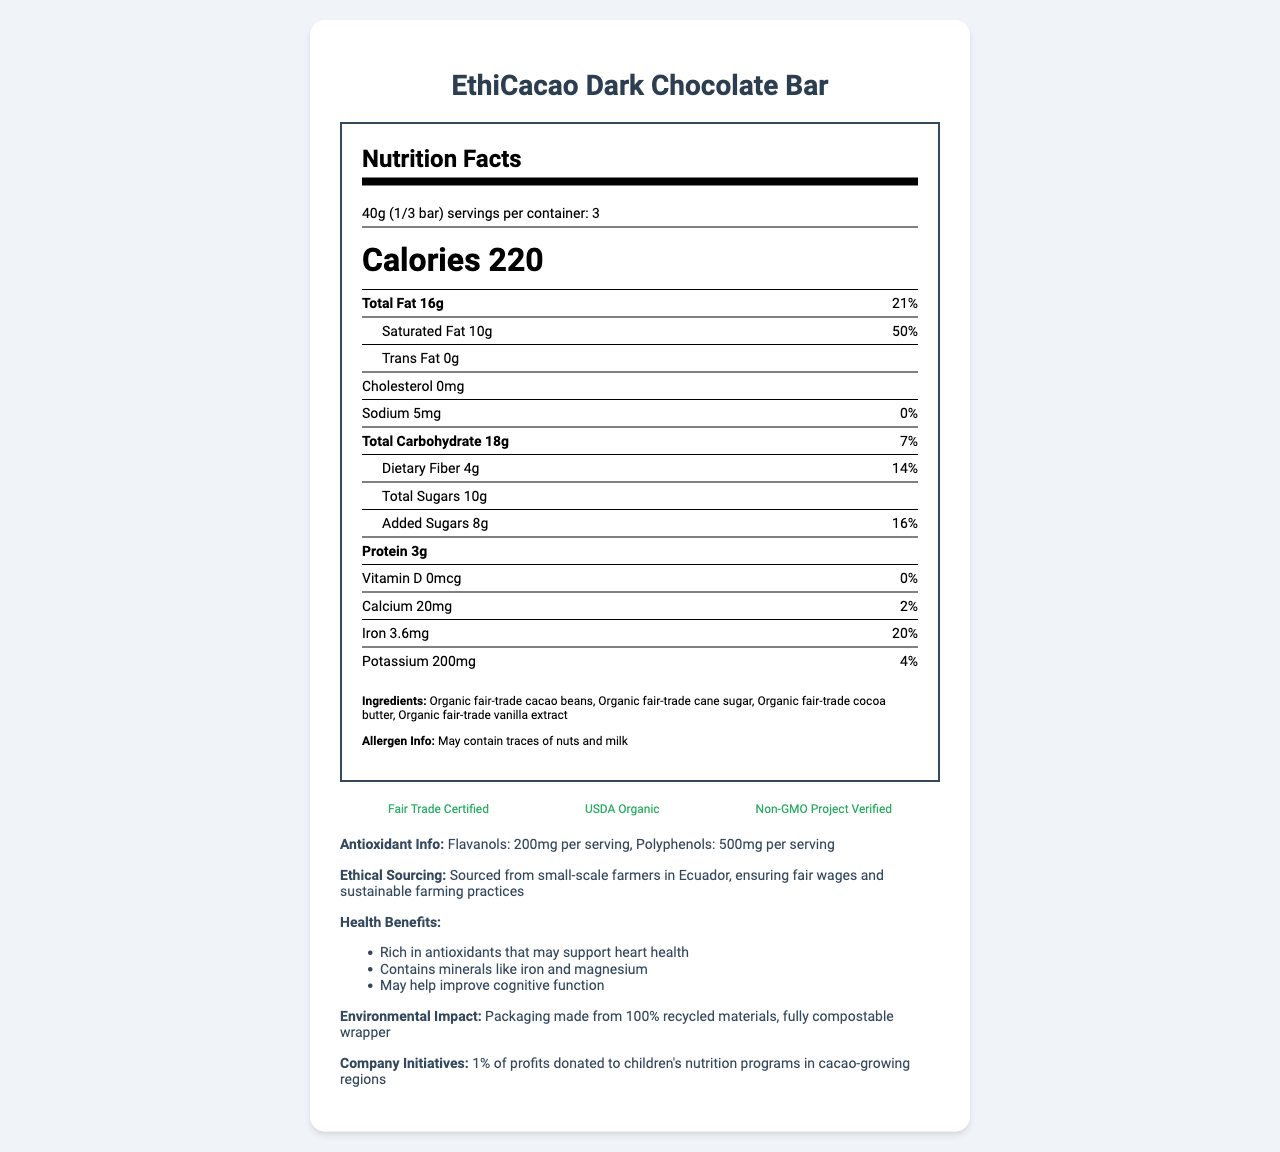what is the serving size of EthiCacao Dark Chocolate Bar? The document indicates that the serving size is specified as 40g (1/3 bar).
Answer: 40g (1/3 bar) how many servings per container are there? The document specifies that there are 3 servings per container of the chocolate bar.
Answer: 3 what are the total calories per serving? The number of calories per serving is listed as 220 in the document.
Answer: 220 what percentage of daily value does the saturated fat content represent? According to the document, the saturated fat content is 10g which represents 50% of the daily value.
Answer: 50% how much iron is in each serving and what percentage of daily value does it provide? The document notes that each serving contains 3.6mg of iron, which is 20% of the daily value.
Answer: 3.6mg, 20% which ingredient listed is not organic? The document lists all the ingredients as organic: Organic fair-trade cacao beans, Organic fair-trade cane sugar, Organic fair-trade cocoa butter, and Organic fair-trade vanilla extract.
Answer: None, all ingredients are organic what are the potential allergens in this product? The document specifies that the chocolate bar may contain traces of nuts and milk.
Answer: Trace amounts of nuts and milk what certifications does EthiCacao Dark Chocolate Bar have? A. Fair Trade Certified B. USDA Organic C. Non-GMO Project Verified D. All of the above The document lists the certifications as Fair Trade Certified, USDA Organic, and Non-GMO Project Verified.
Answer: D which of the following is NOT one of the company’s initiatives? A. 1% of profits donated to children's nutrition programs B. Sponsoring local marathons C. Ethical sourcing from Ecuador D. Using 100% recycled materials for packaging The document details several initiatives including donating 1% of profits to children's nutrition programs, ethical sourcing from Ecuador, and using 100% recycled packaging. Sponsoring local marathons is not mentioned.
Answer: B does the company claim environmental impact measures? The document states that the packaging is made from 100% recycled materials and is fully compostable.
Answer: Yes summarize the main benefits noted for the EthiCacao Dark Chocolate Bar. The product is highlighted as being rich in antioxidants (flavanols and polyphenols), high in minerals like iron and magnesium, and beneficial for heart health and cognitive function. Additionally, it is sourced ethically from small-scale farmers in Ecuador, and the packaging is environmentally friendly.
Answer: Antioxidant-rich, high in minerals, supports heart health and cognitive function, ethically sourced, environmentally friendly packaging what is the exact amount of vitamin D per serving in the chocolate bar? The document mentions that the vitamin D content per serving is 0mcg.
Answer: 0mcg how many grams of dietary fiber are in one serving and what is the percentage of daily value? Each serving contains 4g of dietary fiber, which represents 14% of the daily value.
Answer: 4g, 14% what amount of flavanols does each serving of the EthiCacao Dark Chocolate Bar contain? The antioxidant information specifies that each serving contains 200mg of flavanols.
Answer: 200mg what is the amount of sodium per serving and its daily value percentage? The sodium content per serving is 5mg, which is 0% of the daily value.
Answer: 5mg, 0% how does the company’s ethical sourcing impact farm workers? The document states that the chocolate is sourced from small-scale farmers in Ecuador, ensuring fair wages and sustainable farming practices.
Answer: Ensures fair wages and sustainable farming practices what is the amount of cholesterol in a serving of EthiCacao Dark Chocolate Bar? The document lists the cholesterol content as 0mg per serving.
Answer: 0mg what is the proportion of added sugars to total sugars per serving? The document indicates that out of the 10g of total sugars per serving, 8g are added sugars.
Answer: 8g out of 10g what material is the packaging made from and is it recyclable? The document specifies that the packaging is made from 100% recycled materials and is fully compostable.
Answer: 100% recycled materials, fully compostable how much protein is in each serving? Each serving contains 3g of protein as noted in the document.
Answer: 3g does the document include the price of the EthiCacao Dark Chocolate Bar? The document does not provide any information about the price of the chocolate bar.
Answer: Cannot be determined 